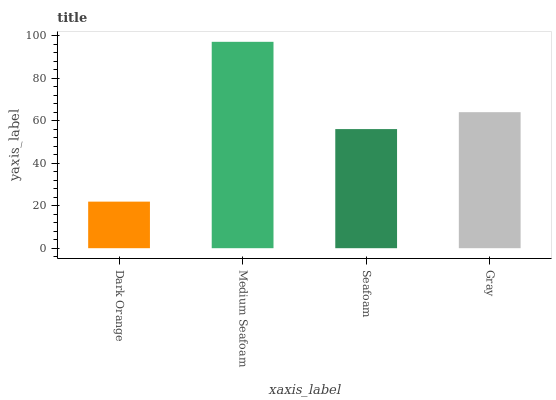Is Dark Orange the minimum?
Answer yes or no. Yes. Is Medium Seafoam the maximum?
Answer yes or no. Yes. Is Seafoam the minimum?
Answer yes or no. No. Is Seafoam the maximum?
Answer yes or no. No. Is Medium Seafoam greater than Seafoam?
Answer yes or no. Yes. Is Seafoam less than Medium Seafoam?
Answer yes or no. Yes. Is Seafoam greater than Medium Seafoam?
Answer yes or no. No. Is Medium Seafoam less than Seafoam?
Answer yes or no. No. Is Gray the high median?
Answer yes or no. Yes. Is Seafoam the low median?
Answer yes or no. Yes. Is Dark Orange the high median?
Answer yes or no. No. Is Gray the low median?
Answer yes or no. No. 